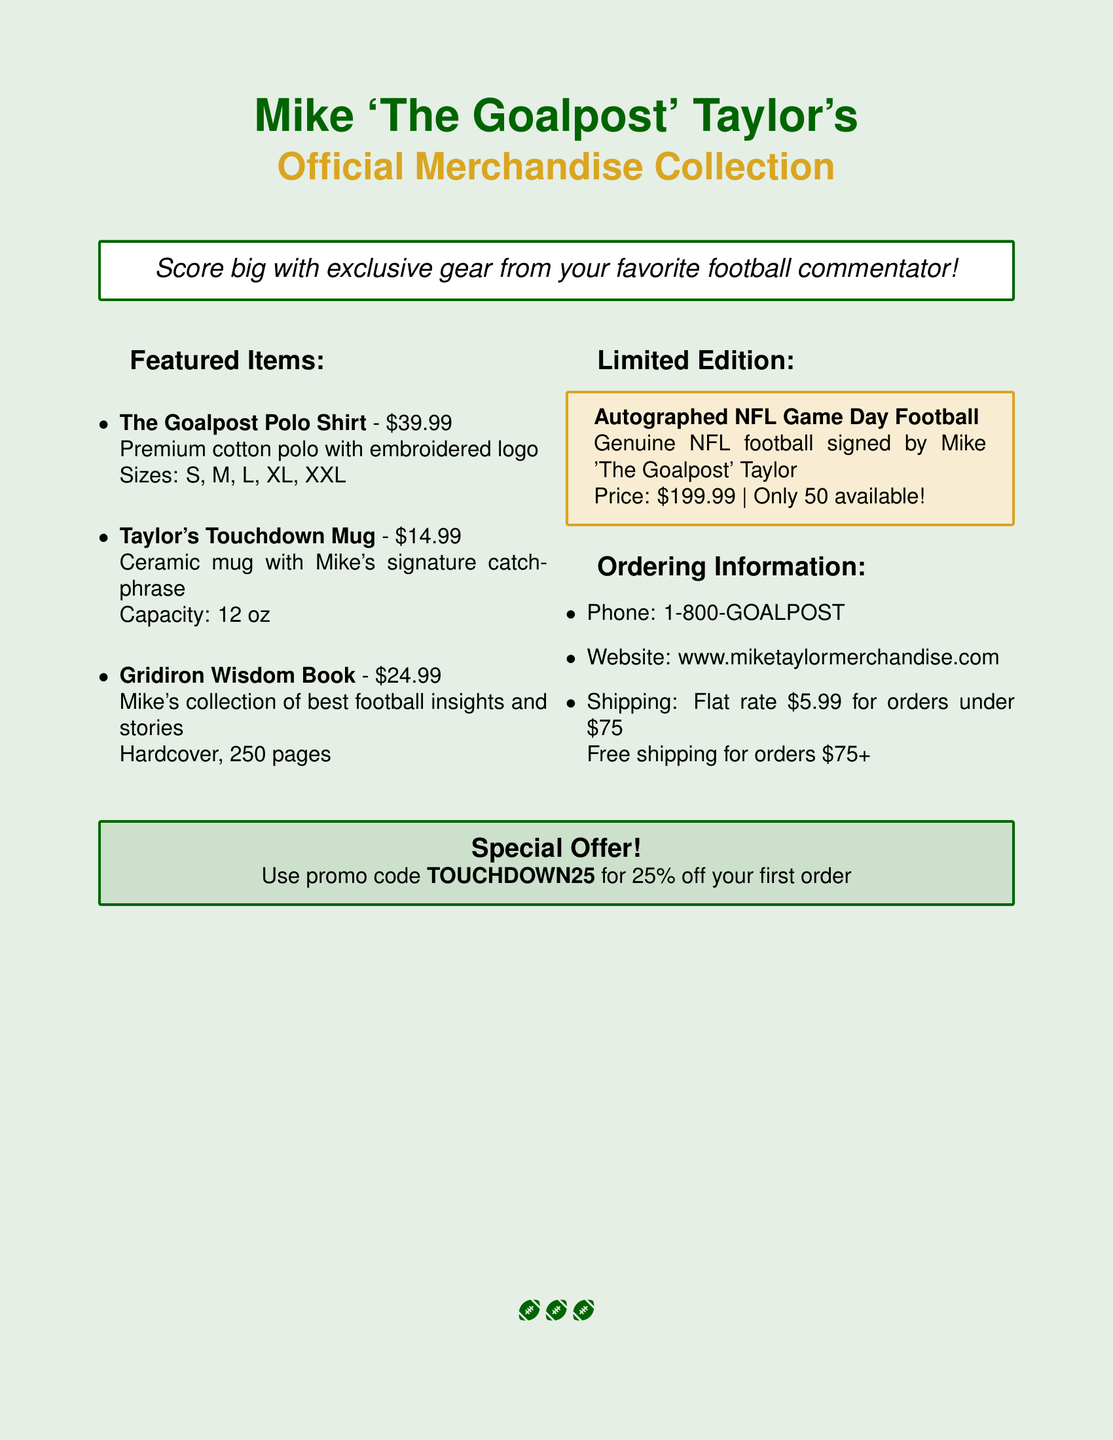What is the title of the merchandise catalog? The title of the merchandise catalog is prominently stated at the beginning.
Answer: Mike 'The Goalpost' Taylor's Official Merchandise Collection What is the price of The Goalpost Polo Shirt? The price of The Goalpost Polo Shirt is listed under featured items.
Answer: $39.99 How many autographed NFL Game Day footballs are available? The quantity available of the limited edition item is specified.
Answer: 50 What discount is offered with the promo code? The promo code offers a specific percentage off, which is mentioned in the special offer section.
Answer: 25% off your first order What is the shipping cost for orders under $75? The shipping information provides details for orders below a certain amount.
Answer: Flat rate $5.99 for orders under $75 Which item has Mike's signature catchphrase? The item described with Mike's catchphrase is specifically named in the featured items section.
Answer: Taylor's Touchdown Mug What is the capacity of Taylor's Touchdown Mug? The capacity of the mug is provided alongside its description.
Answer: 12 oz What sizes are available for The Goalpost Polo Shirt? The available sizes for the polo shirt are listed clearly.
Answer: S, M, L, XL, XXL Where can you order Mike's merchandise online? The website for ordering is specified in the ordering information section.
Answer: www.miketaylormerchandise.com 